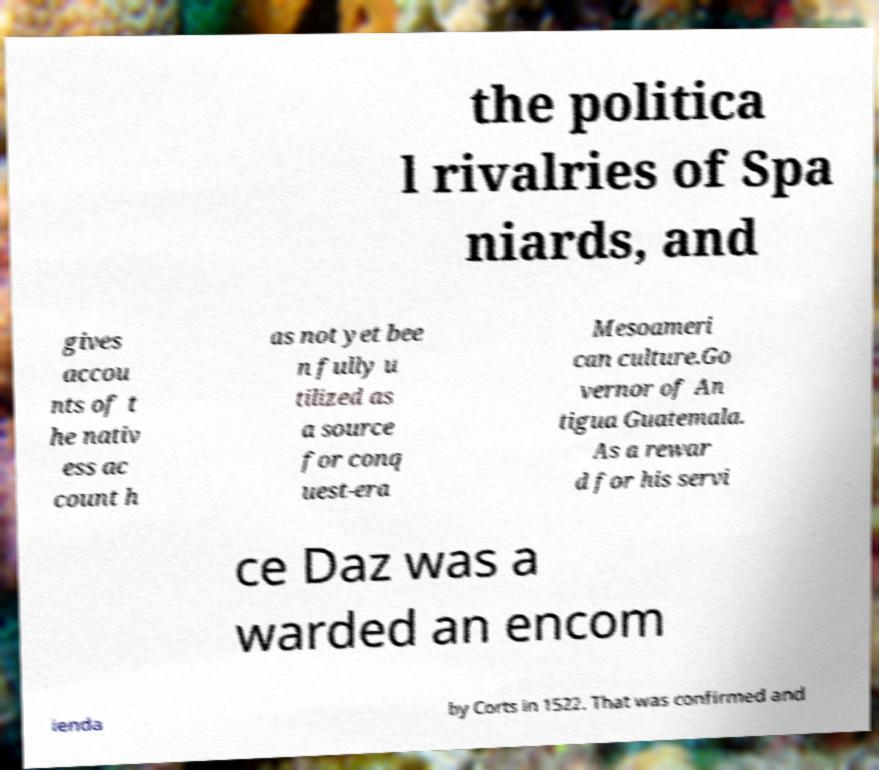There's text embedded in this image that I need extracted. Can you transcribe it verbatim? the politica l rivalries of Spa niards, and gives accou nts of t he nativ ess ac count h as not yet bee n fully u tilized as a source for conq uest-era Mesoameri can culture.Go vernor of An tigua Guatemala. As a rewar d for his servi ce Daz was a warded an encom ienda by Corts in 1522. That was confirmed and 